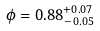<formula> <loc_0><loc_0><loc_500><loc_500>\phi = 0 . 8 8 ^ { + 0 . 0 7 } _ { - 0 . 0 5 }</formula> 